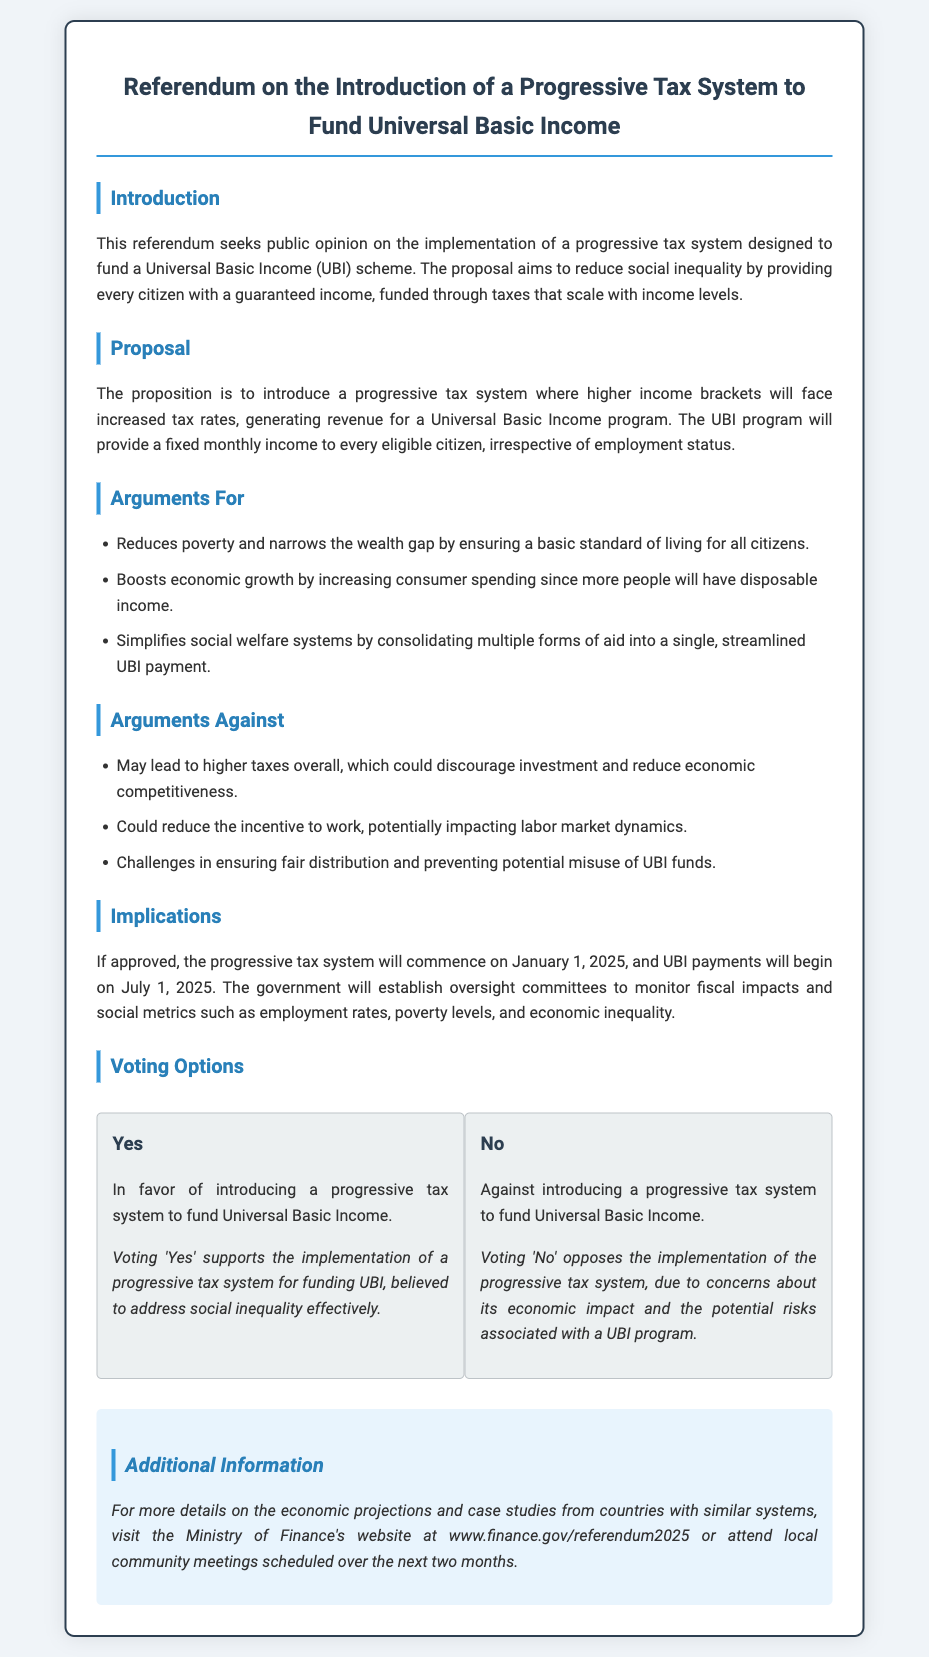What is the title of the referendum? The title of the referendum is found at the top of the document, outlining the primary subject being voted on.
Answer: Referendum on the Introduction of a Progressive Tax System to Fund Universal Basic Income What is the commencement date of the progressive tax system? The document specifies when the new tax system will start, which is essential for understanding implementation timelines.
Answer: January 1, 2025 What type of income is the Universal Basic Income intended to provide? The document describes the nature and intent of the UBI program in relation to citizens.
Answer: A guaranteed income What are two arguments in favor of the proposal? The document lists several arguments for and against the proposal; this question asks for examples supporting the implementation.
Answer: Reduces poverty and boosts economic growth What is a concern regarding the progressive tax system? The document outlines potential drawbacks to the proposed tax system and UBI program.
Answer: Higher taxes overall What is the proposed start date for UBI payments? The document indicates when citizens can expect to start receiving UBI, providing insight into the financial implications.
Answer: July 1, 2025 What is one role of the oversight committees established by the government? The document mentions the responsibilities of these committees, which are crucial for monitoring the tax and UBI system's impacts.
Answer: Monitor fiscal impacts What are the voting options listed in the document? A key element of a referendum document is the options available to voters; this question looks for the specific choices presented.
Answer: Yes and No Where can more information about the referendum be found? The document directs readers to specific resources for additional details, essential for informed voting.
Answer: Ministry of Finance's website 